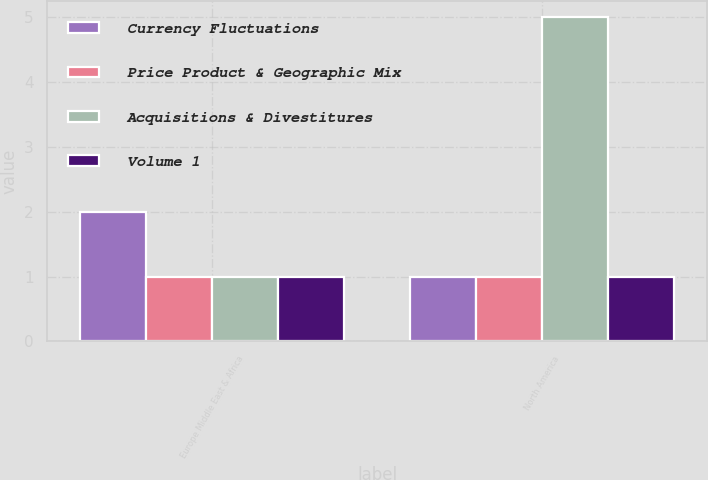<chart> <loc_0><loc_0><loc_500><loc_500><stacked_bar_chart><ecel><fcel>Europe Middle East & Africa<fcel>North America<nl><fcel>Currency Fluctuations<fcel>2<fcel>1<nl><fcel>Price Product & Geographic Mix<fcel>1<fcel>1<nl><fcel>Acquisitions & Divestitures<fcel>1<fcel>5<nl><fcel>Volume 1<fcel>1<fcel>1<nl></chart> 